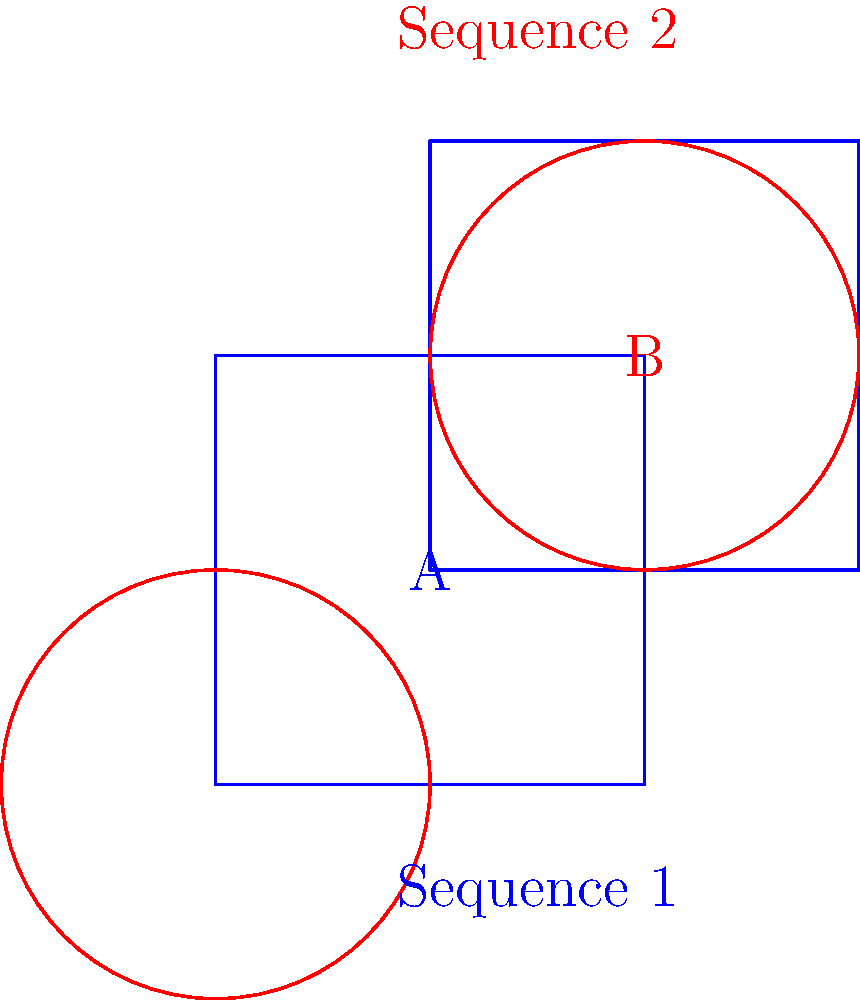In Castlevania, consider two monster transformation sequences: Sequence 1 (blue) shows a square morphing into a larger square, while Sequence 2 (red) depicts a circle expanding into a larger circle. Are these transformation sequences homeomorphic to each other? Justify your answer using topological concepts. To determine if the two transformation sequences are homeomorphic, we need to consider the following steps:

1. Definition of homeomorphism: Two topological spaces are homeomorphic if there exists a continuous bijective function with a continuous inverse between them.

2. Analyze Sequence 1 (blue):
   - Initial state: A square
   - Final state: A larger square
   - Transformation: Continuous expansion and translation

3. Analyze Sequence 2 (red):
   - Initial state: A circle
   - Final state: A larger circle
   - Transformation: Continuous expansion and translation

4. Compare the properties:
   - Both sequences maintain the same shape throughout the transformation.
   - Both transformations are continuous and reversible.
   - The initial and final states in both sequences are topologically equivalent to their counterparts (square to square, circle to circle).

5. Consider the topological properties:
   - Squares and circles are both simply connected, compact, and have a single boundary component.
   - The transformations preserve these topological properties throughout the sequences.

6. Construct a homeomorphism:
   - We can define a continuous bijective function that maps points from Sequence 1 to Sequence 2 at each stage of the transformation.
   - This function would map the boundary of the square to the boundary of the circle, and the interior points accordingly.
   - The inverse of this function would also be continuous.

7. Conclusion:
   Since we can establish a homeomorphism between the two sequences at each stage of the transformation, preserving topological properties throughout, the two transformation sequences are indeed homeomorphic.
Answer: Yes, the sequences are homeomorphic. 